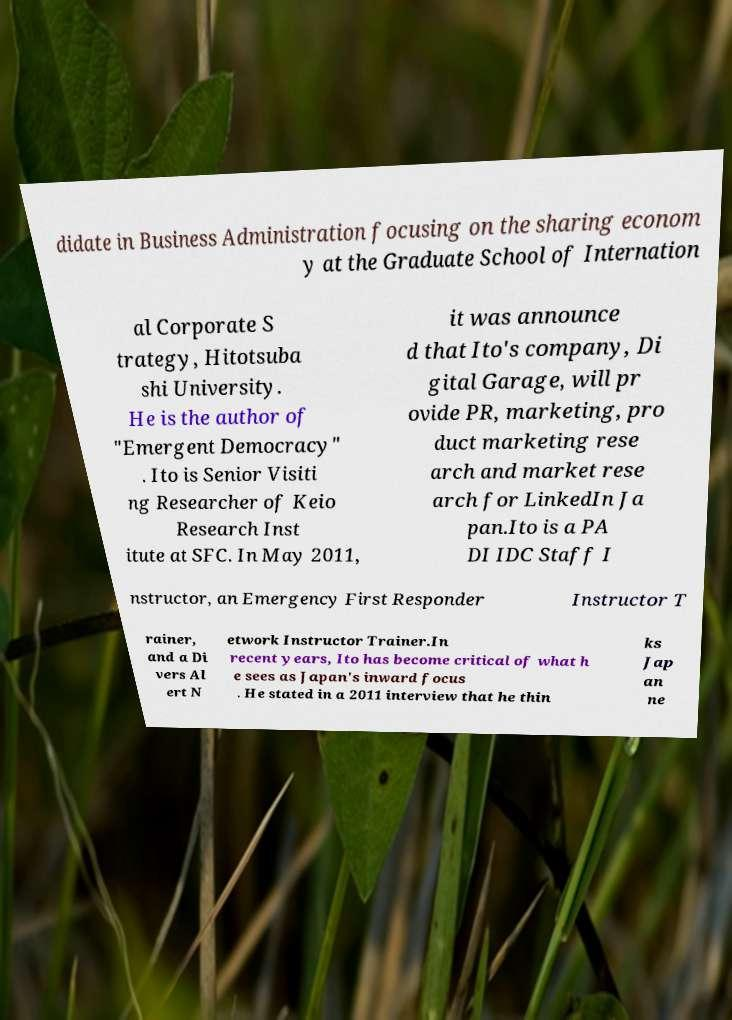What messages or text are displayed in this image? I need them in a readable, typed format. didate in Business Administration focusing on the sharing econom y at the Graduate School of Internation al Corporate S trategy, Hitotsuba shi University. He is the author of "Emergent Democracy" . Ito is Senior Visiti ng Researcher of Keio Research Inst itute at SFC. In May 2011, it was announce d that Ito's company, Di gital Garage, will pr ovide PR, marketing, pro duct marketing rese arch and market rese arch for LinkedIn Ja pan.Ito is a PA DI IDC Staff I nstructor, an Emergency First Responder Instructor T rainer, and a Di vers Al ert N etwork Instructor Trainer.In recent years, Ito has become critical of what h e sees as Japan's inward focus . He stated in a 2011 interview that he thin ks Jap an ne 